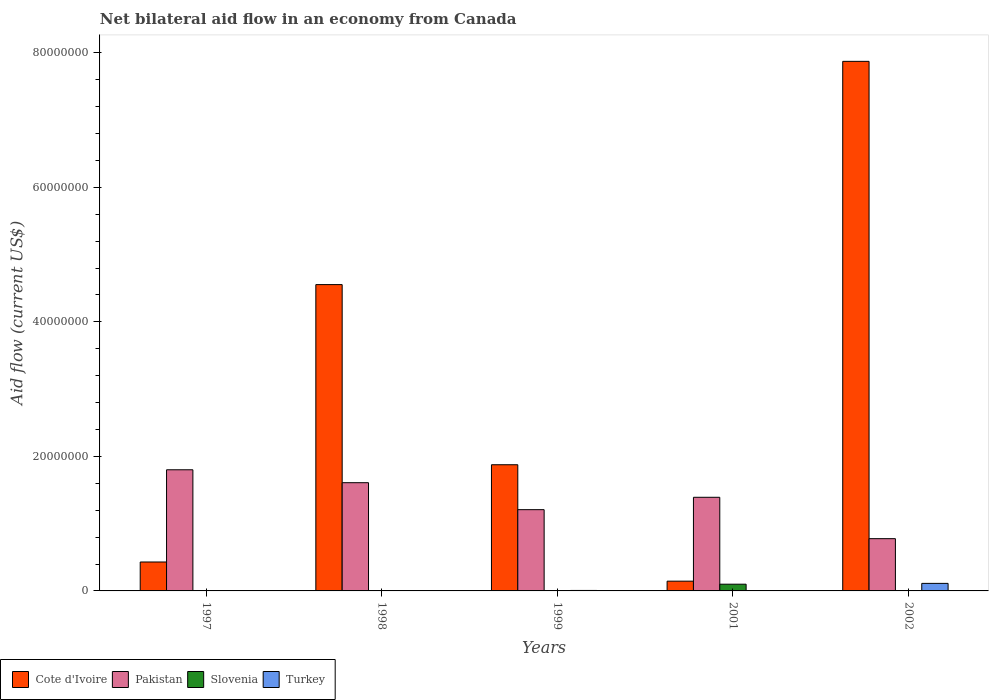How many groups of bars are there?
Keep it short and to the point. 5. In how many cases, is the number of bars for a given year not equal to the number of legend labels?
Ensure brevity in your answer.  3. What is the net bilateral aid flow in Turkey in 2001?
Provide a short and direct response. 0. Across all years, what is the maximum net bilateral aid flow in Turkey?
Provide a succinct answer. 1.12e+06. Across all years, what is the minimum net bilateral aid flow in Pakistan?
Provide a short and direct response. 7.77e+06. What is the total net bilateral aid flow in Turkey in the graph?
Your answer should be very brief. 1.19e+06. What is the difference between the net bilateral aid flow in Pakistan in 2001 and that in 2002?
Offer a terse response. 6.15e+06. What is the difference between the net bilateral aid flow in Slovenia in 2001 and the net bilateral aid flow in Pakistan in 2002?
Provide a succinct answer. -6.77e+06. What is the average net bilateral aid flow in Pakistan per year?
Your answer should be very brief. 1.36e+07. In the year 1999, what is the difference between the net bilateral aid flow in Cote d'Ivoire and net bilateral aid flow in Turkey?
Give a very brief answer. 1.87e+07. In how many years, is the net bilateral aid flow in Slovenia greater than 68000000 US$?
Your answer should be compact. 0. What is the ratio of the net bilateral aid flow in Pakistan in 1999 to that in 2001?
Keep it short and to the point. 0.87. Is the net bilateral aid flow in Cote d'Ivoire in 1997 less than that in 1998?
Keep it short and to the point. Yes. What is the difference between the highest and the second highest net bilateral aid flow in Slovenia?
Give a very brief answer. 9.80e+05. What is the difference between the highest and the lowest net bilateral aid flow in Pakistan?
Your response must be concise. 1.02e+07. In how many years, is the net bilateral aid flow in Slovenia greater than the average net bilateral aid flow in Slovenia taken over all years?
Keep it short and to the point. 1. Is it the case that in every year, the sum of the net bilateral aid flow in Turkey and net bilateral aid flow in Pakistan is greater than the net bilateral aid flow in Slovenia?
Provide a short and direct response. Yes. Are all the bars in the graph horizontal?
Make the answer very short. No. Does the graph contain any zero values?
Keep it short and to the point. Yes. Does the graph contain grids?
Your answer should be very brief. No. Where does the legend appear in the graph?
Provide a succinct answer. Bottom left. How are the legend labels stacked?
Provide a short and direct response. Horizontal. What is the title of the graph?
Offer a very short reply. Net bilateral aid flow in an economy from Canada. What is the Aid flow (current US$) in Cote d'Ivoire in 1997?
Ensure brevity in your answer.  4.30e+06. What is the Aid flow (current US$) of Pakistan in 1997?
Your answer should be compact. 1.80e+07. What is the Aid flow (current US$) of Turkey in 1997?
Your answer should be very brief. 0. What is the Aid flow (current US$) in Cote d'Ivoire in 1998?
Provide a short and direct response. 4.55e+07. What is the Aid flow (current US$) in Pakistan in 1998?
Your answer should be compact. 1.61e+07. What is the Aid flow (current US$) of Turkey in 1998?
Provide a succinct answer. 0. What is the Aid flow (current US$) in Cote d'Ivoire in 1999?
Give a very brief answer. 1.88e+07. What is the Aid flow (current US$) of Pakistan in 1999?
Your response must be concise. 1.21e+07. What is the Aid flow (current US$) in Cote d'Ivoire in 2001?
Provide a short and direct response. 1.45e+06. What is the Aid flow (current US$) in Pakistan in 2001?
Provide a short and direct response. 1.39e+07. What is the Aid flow (current US$) of Slovenia in 2001?
Keep it short and to the point. 1.00e+06. What is the Aid flow (current US$) in Turkey in 2001?
Provide a succinct answer. 0. What is the Aid flow (current US$) in Cote d'Ivoire in 2002?
Keep it short and to the point. 7.87e+07. What is the Aid flow (current US$) of Pakistan in 2002?
Your response must be concise. 7.77e+06. What is the Aid flow (current US$) in Turkey in 2002?
Your response must be concise. 1.12e+06. Across all years, what is the maximum Aid flow (current US$) of Cote d'Ivoire?
Make the answer very short. 7.87e+07. Across all years, what is the maximum Aid flow (current US$) of Pakistan?
Your response must be concise. 1.80e+07. Across all years, what is the maximum Aid flow (current US$) in Slovenia?
Keep it short and to the point. 1.00e+06. Across all years, what is the maximum Aid flow (current US$) of Turkey?
Your response must be concise. 1.12e+06. Across all years, what is the minimum Aid flow (current US$) of Cote d'Ivoire?
Keep it short and to the point. 1.45e+06. Across all years, what is the minimum Aid flow (current US$) in Pakistan?
Offer a very short reply. 7.77e+06. Across all years, what is the minimum Aid flow (current US$) of Slovenia?
Provide a short and direct response. 10000. Across all years, what is the minimum Aid flow (current US$) of Turkey?
Your answer should be very brief. 0. What is the total Aid flow (current US$) of Cote d'Ivoire in the graph?
Offer a very short reply. 1.49e+08. What is the total Aid flow (current US$) of Pakistan in the graph?
Provide a short and direct response. 6.79e+07. What is the total Aid flow (current US$) in Slovenia in the graph?
Provide a succinct answer. 1.05e+06. What is the total Aid flow (current US$) in Turkey in the graph?
Keep it short and to the point. 1.19e+06. What is the difference between the Aid flow (current US$) in Cote d'Ivoire in 1997 and that in 1998?
Keep it short and to the point. -4.12e+07. What is the difference between the Aid flow (current US$) of Pakistan in 1997 and that in 1998?
Provide a succinct answer. 1.92e+06. What is the difference between the Aid flow (current US$) of Slovenia in 1997 and that in 1998?
Give a very brief answer. 0. What is the difference between the Aid flow (current US$) in Cote d'Ivoire in 1997 and that in 1999?
Your answer should be compact. -1.45e+07. What is the difference between the Aid flow (current US$) in Pakistan in 1997 and that in 1999?
Provide a succinct answer. 5.93e+06. What is the difference between the Aid flow (current US$) in Cote d'Ivoire in 1997 and that in 2001?
Your answer should be very brief. 2.85e+06. What is the difference between the Aid flow (current US$) in Pakistan in 1997 and that in 2001?
Offer a very short reply. 4.09e+06. What is the difference between the Aid flow (current US$) in Slovenia in 1997 and that in 2001?
Offer a terse response. -9.90e+05. What is the difference between the Aid flow (current US$) in Cote d'Ivoire in 1997 and that in 2002?
Provide a short and direct response. -7.44e+07. What is the difference between the Aid flow (current US$) in Pakistan in 1997 and that in 2002?
Give a very brief answer. 1.02e+07. What is the difference between the Aid flow (current US$) in Slovenia in 1997 and that in 2002?
Offer a terse response. 0. What is the difference between the Aid flow (current US$) in Cote d'Ivoire in 1998 and that in 1999?
Offer a very short reply. 2.68e+07. What is the difference between the Aid flow (current US$) in Pakistan in 1998 and that in 1999?
Ensure brevity in your answer.  4.01e+06. What is the difference between the Aid flow (current US$) in Slovenia in 1998 and that in 1999?
Your answer should be compact. -10000. What is the difference between the Aid flow (current US$) of Cote d'Ivoire in 1998 and that in 2001?
Provide a short and direct response. 4.41e+07. What is the difference between the Aid flow (current US$) in Pakistan in 1998 and that in 2001?
Offer a very short reply. 2.17e+06. What is the difference between the Aid flow (current US$) in Slovenia in 1998 and that in 2001?
Your answer should be very brief. -9.90e+05. What is the difference between the Aid flow (current US$) of Cote d'Ivoire in 1998 and that in 2002?
Provide a succinct answer. -3.32e+07. What is the difference between the Aid flow (current US$) in Pakistan in 1998 and that in 2002?
Provide a succinct answer. 8.32e+06. What is the difference between the Aid flow (current US$) of Cote d'Ivoire in 1999 and that in 2001?
Provide a short and direct response. 1.73e+07. What is the difference between the Aid flow (current US$) of Pakistan in 1999 and that in 2001?
Your answer should be very brief. -1.84e+06. What is the difference between the Aid flow (current US$) in Slovenia in 1999 and that in 2001?
Offer a terse response. -9.80e+05. What is the difference between the Aid flow (current US$) of Cote d'Ivoire in 1999 and that in 2002?
Provide a succinct answer. -6.00e+07. What is the difference between the Aid flow (current US$) of Pakistan in 1999 and that in 2002?
Offer a terse response. 4.31e+06. What is the difference between the Aid flow (current US$) of Turkey in 1999 and that in 2002?
Give a very brief answer. -1.05e+06. What is the difference between the Aid flow (current US$) in Cote d'Ivoire in 2001 and that in 2002?
Offer a very short reply. -7.73e+07. What is the difference between the Aid flow (current US$) of Pakistan in 2001 and that in 2002?
Your answer should be compact. 6.15e+06. What is the difference between the Aid flow (current US$) of Slovenia in 2001 and that in 2002?
Make the answer very short. 9.90e+05. What is the difference between the Aid flow (current US$) of Cote d'Ivoire in 1997 and the Aid flow (current US$) of Pakistan in 1998?
Your answer should be very brief. -1.18e+07. What is the difference between the Aid flow (current US$) in Cote d'Ivoire in 1997 and the Aid flow (current US$) in Slovenia in 1998?
Provide a short and direct response. 4.29e+06. What is the difference between the Aid flow (current US$) of Pakistan in 1997 and the Aid flow (current US$) of Slovenia in 1998?
Give a very brief answer. 1.80e+07. What is the difference between the Aid flow (current US$) of Cote d'Ivoire in 1997 and the Aid flow (current US$) of Pakistan in 1999?
Keep it short and to the point. -7.78e+06. What is the difference between the Aid flow (current US$) in Cote d'Ivoire in 1997 and the Aid flow (current US$) in Slovenia in 1999?
Offer a terse response. 4.28e+06. What is the difference between the Aid flow (current US$) of Cote d'Ivoire in 1997 and the Aid flow (current US$) of Turkey in 1999?
Your response must be concise. 4.23e+06. What is the difference between the Aid flow (current US$) in Pakistan in 1997 and the Aid flow (current US$) in Slovenia in 1999?
Provide a short and direct response. 1.80e+07. What is the difference between the Aid flow (current US$) in Pakistan in 1997 and the Aid flow (current US$) in Turkey in 1999?
Give a very brief answer. 1.79e+07. What is the difference between the Aid flow (current US$) of Slovenia in 1997 and the Aid flow (current US$) of Turkey in 1999?
Provide a succinct answer. -6.00e+04. What is the difference between the Aid flow (current US$) of Cote d'Ivoire in 1997 and the Aid flow (current US$) of Pakistan in 2001?
Keep it short and to the point. -9.62e+06. What is the difference between the Aid flow (current US$) in Cote d'Ivoire in 1997 and the Aid flow (current US$) in Slovenia in 2001?
Give a very brief answer. 3.30e+06. What is the difference between the Aid flow (current US$) of Pakistan in 1997 and the Aid flow (current US$) of Slovenia in 2001?
Offer a very short reply. 1.70e+07. What is the difference between the Aid flow (current US$) of Cote d'Ivoire in 1997 and the Aid flow (current US$) of Pakistan in 2002?
Offer a terse response. -3.47e+06. What is the difference between the Aid flow (current US$) of Cote d'Ivoire in 1997 and the Aid flow (current US$) of Slovenia in 2002?
Ensure brevity in your answer.  4.29e+06. What is the difference between the Aid flow (current US$) of Cote d'Ivoire in 1997 and the Aid flow (current US$) of Turkey in 2002?
Your answer should be compact. 3.18e+06. What is the difference between the Aid flow (current US$) of Pakistan in 1997 and the Aid flow (current US$) of Slovenia in 2002?
Provide a short and direct response. 1.80e+07. What is the difference between the Aid flow (current US$) in Pakistan in 1997 and the Aid flow (current US$) in Turkey in 2002?
Ensure brevity in your answer.  1.69e+07. What is the difference between the Aid flow (current US$) in Slovenia in 1997 and the Aid flow (current US$) in Turkey in 2002?
Make the answer very short. -1.11e+06. What is the difference between the Aid flow (current US$) in Cote d'Ivoire in 1998 and the Aid flow (current US$) in Pakistan in 1999?
Your response must be concise. 3.35e+07. What is the difference between the Aid flow (current US$) of Cote d'Ivoire in 1998 and the Aid flow (current US$) of Slovenia in 1999?
Keep it short and to the point. 4.55e+07. What is the difference between the Aid flow (current US$) in Cote d'Ivoire in 1998 and the Aid flow (current US$) in Turkey in 1999?
Your answer should be compact. 4.55e+07. What is the difference between the Aid flow (current US$) of Pakistan in 1998 and the Aid flow (current US$) of Slovenia in 1999?
Offer a very short reply. 1.61e+07. What is the difference between the Aid flow (current US$) in Pakistan in 1998 and the Aid flow (current US$) in Turkey in 1999?
Your response must be concise. 1.60e+07. What is the difference between the Aid flow (current US$) in Cote d'Ivoire in 1998 and the Aid flow (current US$) in Pakistan in 2001?
Ensure brevity in your answer.  3.16e+07. What is the difference between the Aid flow (current US$) of Cote d'Ivoire in 1998 and the Aid flow (current US$) of Slovenia in 2001?
Provide a succinct answer. 4.45e+07. What is the difference between the Aid flow (current US$) in Pakistan in 1998 and the Aid flow (current US$) in Slovenia in 2001?
Keep it short and to the point. 1.51e+07. What is the difference between the Aid flow (current US$) in Cote d'Ivoire in 1998 and the Aid flow (current US$) in Pakistan in 2002?
Offer a terse response. 3.78e+07. What is the difference between the Aid flow (current US$) of Cote d'Ivoire in 1998 and the Aid flow (current US$) of Slovenia in 2002?
Offer a terse response. 4.55e+07. What is the difference between the Aid flow (current US$) of Cote d'Ivoire in 1998 and the Aid flow (current US$) of Turkey in 2002?
Offer a very short reply. 4.44e+07. What is the difference between the Aid flow (current US$) in Pakistan in 1998 and the Aid flow (current US$) in Slovenia in 2002?
Keep it short and to the point. 1.61e+07. What is the difference between the Aid flow (current US$) in Pakistan in 1998 and the Aid flow (current US$) in Turkey in 2002?
Offer a terse response. 1.50e+07. What is the difference between the Aid flow (current US$) of Slovenia in 1998 and the Aid flow (current US$) of Turkey in 2002?
Give a very brief answer. -1.11e+06. What is the difference between the Aid flow (current US$) in Cote d'Ivoire in 1999 and the Aid flow (current US$) in Pakistan in 2001?
Your answer should be compact. 4.84e+06. What is the difference between the Aid flow (current US$) of Cote d'Ivoire in 1999 and the Aid flow (current US$) of Slovenia in 2001?
Give a very brief answer. 1.78e+07. What is the difference between the Aid flow (current US$) in Pakistan in 1999 and the Aid flow (current US$) in Slovenia in 2001?
Your answer should be very brief. 1.11e+07. What is the difference between the Aid flow (current US$) in Cote d'Ivoire in 1999 and the Aid flow (current US$) in Pakistan in 2002?
Ensure brevity in your answer.  1.10e+07. What is the difference between the Aid flow (current US$) in Cote d'Ivoire in 1999 and the Aid flow (current US$) in Slovenia in 2002?
Offer a terse response. 1.88e+07. What is the difference between the Aid flow (current US$) in Cote d'Ivoire in 1999 and the Aid flow (current US$) in Turkey in 2002?
Make the answer very short. 1.76e+07. What is the difference between the Aid flow (current US$) in Pakistan in 1999 and the Aid flow (current US$) in Slovenia in 2002?
Provide a short and direct response. 1.21e+07. What is the difference between the Aid flow (current US$) of Pakistan in 1999 and the Aid flow (current US$) of Turkey in 2002?
Your response must be concise. 1.10e+07. What is the difference between the Aid flow (current US$) of Slovenia in 1999 and the Aid flow (current US$) of Turkey in 2002?
Provide a short and direct response. -1.10e+06. What is the difference between the Aid flow (current US$) of Cote d'Ivoire in 2001 and the Aid flow (current US$) of Pakistan in 2002?
Your answer should be very brief. -6.32e+06. What is the difference between the Aid flow (current US$) in Cote d'Ivoire in 2001 and the Aid flow (current US$) in Slovenia in 2002?
Provide a short and direct response. 1.44e+06. What is the difference between the Aid flow (current US$) in Pakistan in 2001 and the Aid flow (current US$) in Slovenia in 2002?
Provide a short and direct response. 1.39e+07. What is the difference between the Aid flow (current US$) of Pakistan in 2001 and the Aid flow (current US$) of Turkey in 2002?
Your answer should be compact. 1.28e+07. What is the difference between the Aid flow (current US$) of Slovenia in 2001 and the Aid flow (current US$) of Turkey in 2002?
Offer a very short reply. -1.20e+05. What is the average Aid flow (current US$) in Cote d'Ivoire per year?
Give a very brief answer. 2.98e+07. What is the average Aid flow (current US$) in Pakistan per year?
Offer a terse response. 1.36e+07. What is the average Aid flow (current US$) in Slovenia per year?
Ensure brevity in your answer.  2.10e+05. What is the average Aid flow (current US$) of Turkey per year?
Your response must be concise. 2.38e+05. In the year 1997, what is the difference between the Aid flow (current US$) in Cote d'Ivoire and Aid flow (current US$) in Pakistan?
Offer a very short reply. -1.37e+07. In the year 1997, what is the difference between the Aid flow (current US$) of Cote d'Ivoire and Aid flow (current US$) of Slovenia?
Your response must be concise. 4.29e+06. In the year 1997, what is the difference between the Aid flow (current US$) in Pakistan and Aid flow (current US$) in Slovenia?
Offer a terse response. 1.80e+07. In the year 1998, what is the difference between the Aid flow (current US$) of Cote d'Ivoire and Aid flow (current US$) of Pakistan?
Keep it short and to the point. 2.94e+07. In the year 1998, what is the difference between the Aid flow (current US$) of Cote d'Ivoire and Aid flow (current US$) of Slovenia?
Offer a terse response. 4.55e+07. In the year 1998, what is the difference between the Aid flow (current US$) of Pakistan and Aid flow (current US$) of Slovenia?
Provide a succinct answer. 1.61e+07. In the year 1999, what is the difference between the Aid flow (current US$) in Cote d'Ivoire and Aid flow (current US$) in Pakistan?
Your response must be concise. 6.68e+06. In the year 1999, what is the difference between the Aid flow (current US$) of Cote d'Ivoire and Aid flow (current US$) of Slovenia?
Your answer should be compact. 1.87e+07. In the year 1999, what is the difference between the Aid flow (current US$) in Cote d'Ivoire and Aid flow (current US$) in Turkey?
Give a very brief answer. 1.87e+07. In the year 1999, what is the difference between the Aid flow (current US$) in Pakistan and Aid flow (current US$) in Slovenia?
Give a very brief answer. 1.21e+07. In the year 1999, what is the difference between the Aid flow (current US$) of Pakistan and Aid flow (current US$) of Turkey?
Your answer should be compact. 1.20e+07. In the year 1999, what is the difference between the Aid flow (current US$) in Slovenia and Aid flow (current US$) in Turkey?
Offer a very short reply. -5.00e+04. In the year 2001, what is the difference between the Aid flow (current US$) in Cote d'Ivoire and Aid flow (current US$) in Pakistan?
Make the answer very short. -1.25e+07. In the year 2001, what is the difference between the Aid flow (current US$) in Cote d'Ivoire and Aid flow (current US$) in Slovenia?
Your answer should be compact. 4.50e+05. In the year 2001, what is the difference between the Aid flow (current US$) in Pakistan and Aid flow (current US$) in Slovenia?
Offer a terse response. 1.29e+07. In the year 2002, what is the difference between the Aid flow (current US$) of Cote d'Ivoire and Aid flow (current US$) of Pakistan?
Offer a terse response. 7.10e+07. In the year 2002, what is the difference between the Aid flow (current US$) of Cote d'Ivoire and Aid flow (current US$) of Slovenia?
Your answer should be very brief. 7.87e+07. In the year 2002, what is the difference between the Aid flow (current US$) of Cote d'Ivoire and Aid flow (current US$) of Turkey?
Make the answer very short. 7.76e+07. In the year 2002, what is the difference between the Aid flow (current US$) of Pakistan and Aid flow (current US$) of Slovenia?
Make the answer very short. 7.76e+06. In the year 2002, what is the difference between the Aid flow (current US$) of Pakistan and Aid flow (current US$) of Turkey?
Your response must be concise. 6.65e+06. In the year 2002, what is the difference between the Aid flow (current US$) in Slovenia and Aid flow (current US$) in Turkey?
Provide a short and direct response. -1.11e+06. What is the ratio of the Aid flow (current US$) of Cote d'Ivoire in 1997 to that in 1998?
Keep it short and to the point. 0.09. What is the ratio of the Aid flow (current US$) in Pakistan in 1997 to that in 1998?
Give a very brief answer. 1.12. What is the ratio of the Aid flow (current US$) in Cote d'Ivoire in 1997 to that in 1999?
Ensure brevity in your answer.  0.23. What is the ratio of the Aid flow (current US$) in Pakistan in 1997 to that in 1999?
Provide a short and direct response. 1.49. What is the ratio of the Aid flow (current US$) of Cote d'Ivoire in 1997 to that in 2001?
Give a very brief answer. 2.97. What is the ratio of the Aid flow (current US$) of Pakistan in 1997 to that in 2001?
Your response must be concise. 1.29. What is the ratio of the Aid flow (current US$) of Cote d'Ivoire in 1997 to that in 2002?
Your answer should be very brief. 0.05. What is the ratio of the Aid flow (current US$) of Pakistan in 1997 to that in 2002?
Offer a terse response. 2.32. What is the ratio of the Aid flow (current US$) of Cote d'Ivoire in 1998 to that in 1999?
Ensure brevity in your answer.  2.43. What is the ratio of the Aid flow (current US$) in Pakistan in 1998 to that in 1999?
Your answer should be compact. 1.33. What is the ratio of the Aid flow (current US$) in Cote d'Ivoire in 1998 to that in 2001?
Keep it short and to the point. 31.41. What is the ratio of the Aid flow (current US$) of Pakistan in 1998 to that in 2001?
Offer a very short reply. 1.16. What is the ratio of the Aid flow (current US$) in Slovenia in 1998 to that in 2001?
Provide a succinct answer. 0.01. What is the ratio of the Aid flow (current US$) in Cote d'Ivoire in 1998 to that in 2002?
Offer a terse response. 0.58. What is the ratio of the Aid flow (current US$) of Pakistan in 1998 to that in 2002?
Offer a very short reply. 2.07. What is the ratio of the Aid flow (current US$) of Cote d'Ivoire in 1999 to that in 2001?
Your answer should be compact. 12.94. What is the ratio of the Aid flow (current US$) in Pakistan in 1999 to that in 2001?
Your answer should be very brief. 0.87. What is the ratio of the Aid flow (current US$) of Slovenia in 1999 to that in 2001?
Your answer should be compact. 0.02. What is the ratio of the Aid flow (current US$) of Cote d'Ivoire in 1999 to that in 2002?
Your answer should be very brief. 0.24. What is the ratio of the Aid flow (current US$) in Pakistan in 1999 to that in 2002?
Keep it short and to the point. 1.55. What is the ratio of the Aid flow (current US$) in Turkey in 1999 to that in 2002?
Give a very brief answer. 0.06. What is the ratio of the Aid flow (current US$) in Cote d'Ivoire in 2001 to that in 2002?
Offer a terse response. 0.02. What is the ratio of the Aid flow (current US$) in Pakistan in 2001 to that in 2002?
Offer a terse response. 1.79. What is the difference between the highest and the second highest Aid flow (current US$) of Cote d'Ivoire?
Your answer should be compact. 3.32e+07. What is the difference between the highest and the second highest Aid flow (current US$) in Pakistan?
Give a very brief answer. 1.92e+06. What is the difference between the highest and the second highest Aid flow (current US$) in Slovenia?
Ensure brevity in your answer.  9.80e+05. What is the difference between the highest and the lowest Aid flow (current US$) in Cote d'Ivoire?
Your response must be concise. 7.73e+07. What is the difference between the highest and the lowest Aid flow (current US$) in Pakistan?
Your answer should be compact. 1.02e+07. What is the difference between the highest and the lowest Aid flow (current US$) of Slovenia?
Offer a terse response. 9.90e+05. What is the difference between the highest and the lowest Aid flow (current US$) of Turkey?
Provide a short and direct response. 1.12e+06. 